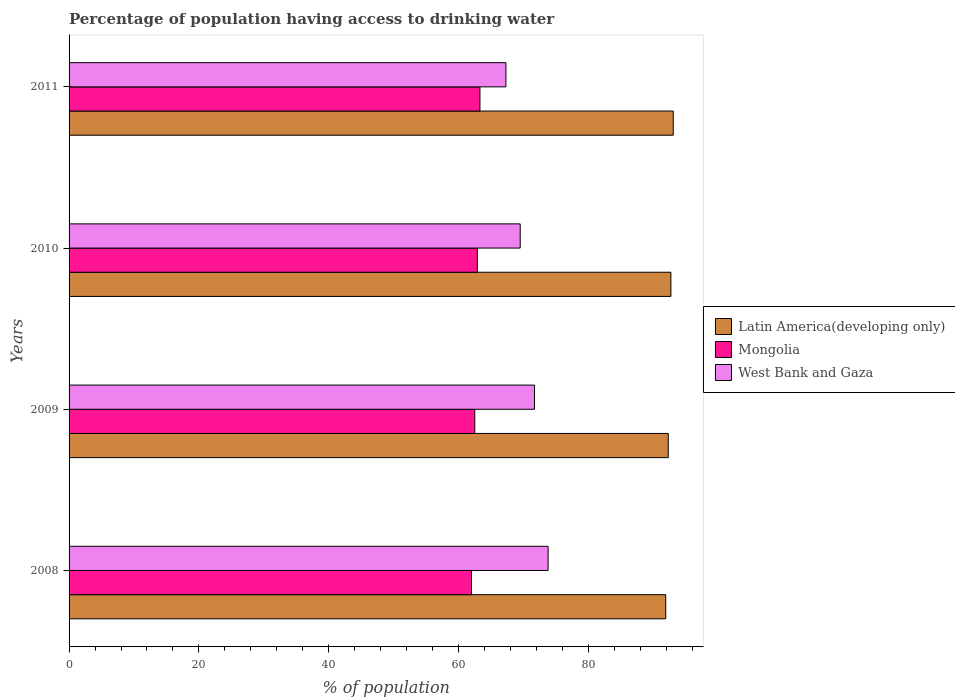What is the label of the 3rd group of bars from the top?
Offer a terse response. 2009. In how many cases, is the number of bars for a given year not equal to the number of legend labels?
Provide a short and direct response. 0. What is the percentage of population having access to drinking water in Latin America(developing only) in 2011?
Offer a terse response. 93.08. Across all years, what is the maximum percentage of population having access to drinking water in West Bank and Gaza?
Keep it short and to the point. 73.8. Across all years, what is the minimum percentage of population having access to drinking water in Mongolia?
Your response must be concise. 62. In which year was the percentage of population having access to drinking water in West Bank and Gaza maximum?
Provide a succinct answer. 2008. What is the total percentage of population having access to drinking water in Latin America(developing only) in the graph?
Keep it short and to the point. 370.02. What is the difference between the percentage of population having access to drinking water in Latin America(developing only) in 2009 and that in 2011?
Provide a short and direct response. -0.77. What is the difference between the percentage of population having access to drinking water in West Bank and Gaza in 2010 and the percentage of population having access to drinking water in Mongolia in 2008?
Offer a very short reply. 7.5. What is the average percentage of population having access to drinking water in Latin America(developing only) per year?
Ensure brevity in your answer.  92.51. In how many years, is the percentage of population having access to drinking water in Latin America(developing only) greater than 24 %?
Your response must be concise. 4. What is the ratio of the percentage of population having access to drinking water in Mongolia in 2008 to that in 2010?
Your answer should be compact. 0.99. What is the difference between the highest and the second highest percentage of population having access to drinking water in West Bank and Gaza?
Offer a very short reply. 2.1. What is the difference between the highest and the lowest percentage of population having access to drinking water in Latin America(developing only)?
Ensure brevity in your answer.  1.16. In how many years, is the percentage of population having access to drinking water in Latin America(developing only) greater than the average percentage of population having access to drinking water in Latin America(developing only) taken over all years?
Offer a terse response. 2. Is the sum of the percentage of population having access to drinking water in Mongolia in 2008 and 2010 greater than the maximum percentage of population having access to drinking water in Latin America(developing only) across all years?
Make the answer very short. Yes. What does the 3rd bar from the top in 2010 represents?
Your answer should be very brief. Latin America(developing only). What does the 2nd bar from the bottom in 2009 represents?
Offer a very short reply. Mongolia. Is it the case that in every year, the sum of the percentage of population having access to drinking water in West Bank and Gaza and percentage of population having access to drinking water in Latin America(developing only) is greater than the percentage of population having access to drinking water in Mongolia?
Offer a terse response. Yes. How many bars are there?
Offer a very short reply. 12. Are all the bars in the graph horizontal?
Make the answer very short. Yes. Are the values on the major ticks of X-axis written in scientific E-notation?
Offer a very short reply. No. Where does the legend appear in the graph?
Provide a short and direct response. Center right. How many legend labels are there?
Ensure brevity in your answer.  3. How are the legend labels stacked?
Ensure brevity in your answer.  Vertical. What is the title of the graph?
Your answer should be compact. Percentage of population having access to drinking water. Does "East Asia (all income levels)" appear as one of the legend labels in the graph?
Provide a succinct answer. No. What is the label or title of the X-axis?
Make the answer very short. % of population. What is the label or title of the Y-axis?
Provide a succinct answer. Years. What is the % of population of Latin America(developing only) in 2008?
Your answer should be very brief. 91.92. What is the % of population in West Bank and Gaza in 2008?
Your answer should be very brief. 73.8. What is the % of population in Latin America(developing only) in 2009?
Your answer should be compact. 92.31. What is the % of population of Mongolia in 2009?
Your answer should be very brief. 62.5. What is the % of population of West Bank and Gaza in 2009?
Give a very brief answer. 71.7. What is the % of population in Latin America(developing only) in 2010?
Provide a short and direct response. 92.71. What is the % of population of Mongolia in 2010?
Provide a succinct answer. 62.9. What is the % of population in West Bank and Gaza in 2010?
Your answer should be compact. 69.5. What is the % of population of Latin America(developing only) in 2011?
Keep it short and to the point. 93.08. What is the % of population in Mongolia in 2011?
Keep it short and to the point. 63.3. What is the % of population in West Bank and Gaza in 2011?
Offer a terse response. 67.3. Across all years, what is the maximum % of population in Latin America(developing only)?
Make the answer very short. 93.08. Across all years, what is the maximum % of population in Mongolia?
Give a very brief answer. 63.3. Across all years, what is the maximum % of population in West Bank and Gaza?
Your answer should be compact. 73.8. Across all years, what is the minimum % of population in Latin America(developing only)?
Ensure brevity in your answer.  91.92. Across all years, what is the minimum % of population of Mongolia?
Your answer should be very brief. 62. Across all years, what is the minimum % of population in West Bank and Gaza?
Offer a very short reply. 67.3. What is the total % of population of Latin America(developing only) in the graph?
Provide a short and direct response. 370.02. What is the total % of population in Mongolia in the graph?
Ensure brevity in your answer.  250.7. What is the total % of population in West Bank and Gaza in the graph?
Offer a terse response. 282.3. What is the difference between the % of population in Latin America(developing only) in 2008 and that in 2009?
Provide a short and direct response. -0.39. What is the difference between the % of population of Mongolia in 2008 and that in 2009?
Your answer should be compact. -0.5. What is the difference between the % of population in West Bank and Gaza in 2008 and that in 2009?
Provide a succinct answer. 2.1. What is the difference between the % of population of Latin America(developing only) in 2008 and that in 2010?
Keep it short and to the point. -0.8. What is the difference between the % of population in Mongolia in 2008 and that in 2010?
Your answer should be compact. -0.9. What is the difference between the % of population of Latin America(developing only) in 2008 and that in 2011?
Give a very brief answer. -1.16. What is the difference between the % of population in West Bank and Gaza in 2008 and that in 2011?
Give a very brief answer. 6.5. What is the difference between the % of population in Latin America(developing only) in 2009 and that in 2010?
Give a very brief answer. -0.4. What is the difference between the % of population in Latin America(developing only) in 2009 and that in 2011?
Keep it short and to the point. -0.77. What is the difference between the % of population in Mongolia in 2009 and that in 2011?
Your answer should be very brief. -0.8. What is the difference between the % of population of Latin America(developing only) in 2010 and that in 2011?
Offer a very short reply. -0.36. What is the difference between the % of population of Latin America(developing only) in 2008 and the % of population of Mongolia in 2009?
Ensure brevity in your answer.  29.42. What is the difference between the % of population in Latin America(developing only) in 2008 and the % of population in West Bank and Gaza in 2009?
Provide a succinct answer. 20.22. What is the difference between the % of population of Mongolia in 2008 and the % of population of West Bank and Gaza in 2009?
Give a very brief answer. -9.7. What is the difference between the % of population of Latin America(developing only) in 2008 and the % of population of Mongolia in 2010?
Keep it short and to the point. 29.02. What is the difference between the % of population of Latin America(developing only) in 2008 and the % of population of West Bank and Gaza in 2010?
Offer a terse response. 22.42. What is the difference between the % of population in Latin America(developing only) in 2008 and the % of population in Mongolia in 2011?
Offer a very short reply. 28.62. What is the difference between the % of population of Latin America(developing only) in 2008 and the % of population of West Bank and Gaza in 2011?
Provide a succinct answer. 24.62. What is the difference between the % of population of Latin America(developing only) in 2009 and the % of population of Mongolia in 2010?
Ensure brevity in your answer.  29.41. What is the difference between the % of population of Latin America(developing only) in 2009 and the % of population of West Bank and Gaza in 2010?
Ensure brevity in your answer.  22.81. What is the difference between the % of population in Mongolia in 2009 and the % of population in West Bank and Gaza in 2010?
Provide a short and direct response. -7. What is the difference between the % of population in Latin America(developing only) in 2009 and the % of population in Mongolia in 2011?
Make the answer very short. 29.01. What is the difference between the % of population of Latin America(developing only) in 2009 and the % of population of West Bank and Gaza in 2011?
Keep it short and to the point. 25.01. What is the difference between the % of population in Latin America(developing only) in 2010 and the % of population in Mongolia in 2011?
Offer a very short reply. 29.41. What is the difference between the % of population of Latin America(developing only) in 2010 and the % of population of West Bank and Gaza in 2011?
Keep it short and to the point. 25.41. What is the average % of population of Latin America(developing only) per year?
Keep it short and to the point. 92.51. What is the average % of population in Mongolia per year?
Provide a short and direct response. 62.67. What is the average % of population of West Bank and Gaza per year?
Offer a terse response. 70.58. In the year 2008, what is the difference between the % of population in Latin America(developing only) and % of population in Mongolia?
Offer a very short reply. 29.92. In the year 2008, what is the difference between the % of population in Latin America(developing only) and % of population in West Bank and Gaza?
Keep it short and to the point. 18.12. In the year 2008, what is the difference between the % of population in Mongolia and % of population in West Bank and Gaza?
Provide a succinct answer. -11.8. In the year 2009, what is the difference between the % of population of Latin America(developing only) and % of population of Mongolia?
Your answer should be compact. 29.81. In the year 2009, what is the difference between the % of population of Latin America(developing only) and % of population of West Bank and Gaza?
Provide a short and direct response. 20.61. In the year 2010, what is the difference between the % of population of Latin America(developing only) and % of population of Mongolia?
Offer a very short reply. 29.81. In the year 2010, what is the difference between the % of population of Latin America(developing only) and % of population of West Bank and Gaza?
Make the answer very short. 23.21. In the year 2011, what is the difference between the % of population of Latin America(developing only) and % of population of Mongolia?
Make the answer very short. 29.78. In the year 2011, what is the difference between the % of population in Latin America(developing only) and % of population in West Bank and Gaza?
Keep it short and to the point. 25.78. In the year 2011, what is the difference between the % of population of Mongolia and % of population of West Bank and Gaza?
Offer a terse response. -4. What is the ratio of the % of population of Latin America(developing only) in 2008 to that in 2009?
Your response must be concise. 1. What is the ratio of the % of population of West Bank and Gaza in 2008 to that in 2009?
Provide a succinct answer. 1.03. What is the ratio of the % of population of Mongolia in 2008 to that in 2010?
Give a very brief answer. 0.99. What is the ratio of the % of population in West Bank and Gaza in 2008 to that in 2010?
Offer a terse response. 1.06. What is the ratio of the % of population in Latin America(developing only) in 2008 to that in 2011?
Offer a terse response. 0.99. What is the ratio of the % of population in Mongolia in 2008 to that in 2011?
Your answer should be compact. 0.98. What is the ratio of the % of population in West Bank and Gaza in 2008 to that in 2011?
Give a very brief answer. 1.1. What is the ratio of the % of population in Mongolia in 2009 to that in 2010?
Provide a succinct answer. 0.99. What is the ratio of the % of population in West Bank and Gaza in 2009 to that in 2010?
Provide a succinct answer. 1.03. What is the ratio of the % of population in Latin America(developing only) in 2009 to that in 2011?
Keep it short and to the point. 0.99. What is the ratio of the % of population in Mongolia in 2009 to that in 2011?
Offer a very short reply. 0.99. What is the ratio of the % of population in West Bank and Gaza in 2009 to that in 2011?
Your response must be concise. 1.07. What is the ratio of the % of population of Latin America(developing only) in 2010 to that in 2011?
Offer a very short reply. 1. What is the ratio of the % of population of West Bank and Gaza in 2010 to that in 2011?
Your answer should be compact. 1.03. What is the difference between the highest and the second highest % of population in Latin America(developing only)?
Your response must be concise. 0.36. What is the difference between the highest and the second highest % of population in Mongolia?
Offer a very short reply. 0.4. What is the difference between the highest and the second highest % of population in West Bank and Gaza?
Ensure brevity in your answer.  2.1. What is the difference between the highest and the lowest % of population of Latin America(developing only)?
Ensure brevity in your answer.  1.16. What is the difference between the highest and the lowest % of population in Mongolia?
Your response must be concise. 1.3. What is the difference between the highest and the lowest % of population in West Bank and Gaza?
Make the answer very short. 6.5. 